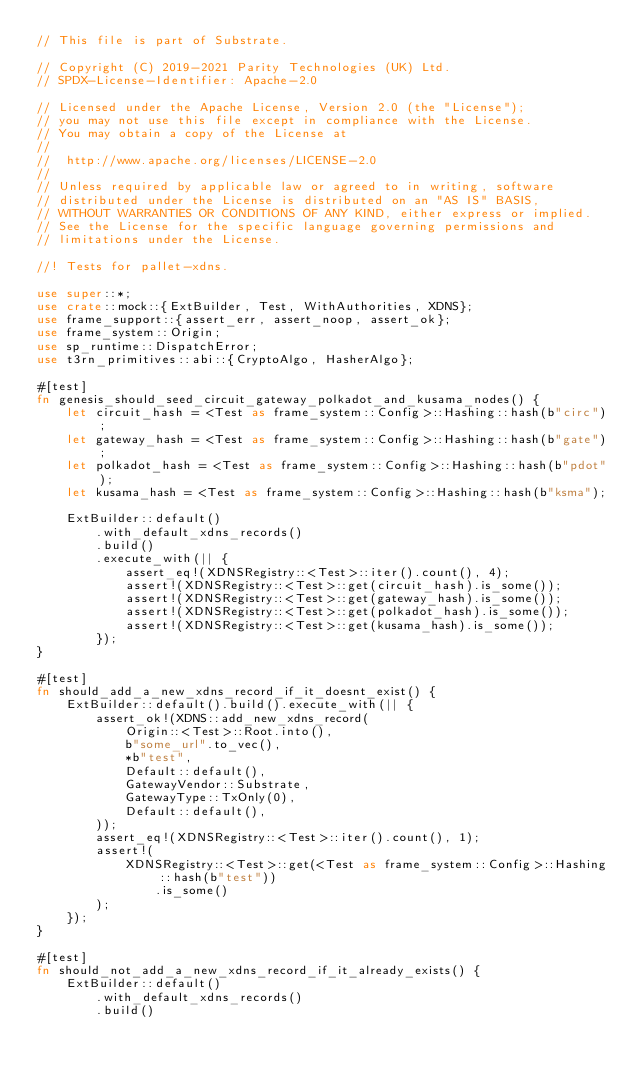<code> <loc_0><loc_0><loc_500><loc_500><_Rust_>// This file is part of Substrate.

// Copyright (C) 2019-2021 Parity Technologies (UK) Ltd.
// SPDX-License-Identifier: Apache-2.0

// Licensed under the Apache License, Version 2.0 (the "License");
// you may not use this file except in compliance with the License.
// You may obtain a copy of the License at
//
// 	http://www.apache.org/licenses/LICENSE-2.0
//
// Unless required by applicable law or agreed to in writing, software
// distributed under the License is distributed on an "AS IS" BASIS,
// WITHOUT WARRANTIES OR CONDITIONS OF ANY KIND, either express or implied.
// See the License for the specific language governing permissions and
// limitations under the License.

//! Tests for pallet-xdns.

use super::*;
use crate::mock::{ExtBuilder, Test, WithAuthorities, XDNS};
use frame_support::{assert_err, assert_noop, assert_ok};
use frame_system::Origin;
use sp_runtime::DispatchError;
use t3rn_primitives::abi::{CryptoAlgo, HasherAlgo};

#[test]
fn genesis_should_seed_circuit_gateway_polkadot_and_kusama_nodes() {
    let circuit_hash = <Test as frame_system::Config>::Hashing::hash(b"circ");
    let gateway_hash = <Test as frame_system::Config>::Hashing::hash(b"gate");
    let polkadot_hash = <Test as frame_system::Config>::Hashing::hash(b"pdot");
    let kusama_hash = <Test as frame_system::Config>::Hashing::hash(b"ksma");

    ExtBuilder::default()
        .with_default_xdns_records()
        .build()
        .execute_with(|| {
            assert_eq!(XDNSRegistry::<Test>::iter().count(), 4);
            assert!(XDNSRegistry::<Test>::get(circuit_hash).is_some());
            assert!(XDNSRegistry::<Test>::get(gateway_hash).is_some());
            assert!(XDNSRegistry::<Test>::get(polkadot_hash).is_some());
            assert!(XDNSRegistry::<Test>::get(kusama_hash).is_some());
        });
}

#[test]
fn should_add_a_new_xdns_record_if_it_doesnt_exist() {
    ExtBuilder::default().build().execute_with(|| {
        assert_ok!(XDNS::add_new_xdns_record(
            Origin::<Test>::Root.into(),
            b"some_url".to_vec(),
            *b"test",
            Default::default(),
            GatewayVendor::Substrate,
            GatewayType::TxOnly(0),
            Default::default(),
        ));
        assert_eq!(XDNSRegistry::<Test>::iter().count(), 1);
        assert!(
            XDNSRegistry::<Test>::get(<Test as frame_system::Config>::Hashing::hash(b"test"))
                .is_some()
        );
    });
}

#[test]
fn should_not_add_a_new_xdns_record_if_it_already_exists() {
    ExtBuilder::default()
        .with_default_xdns_records()
        .build()</code> 